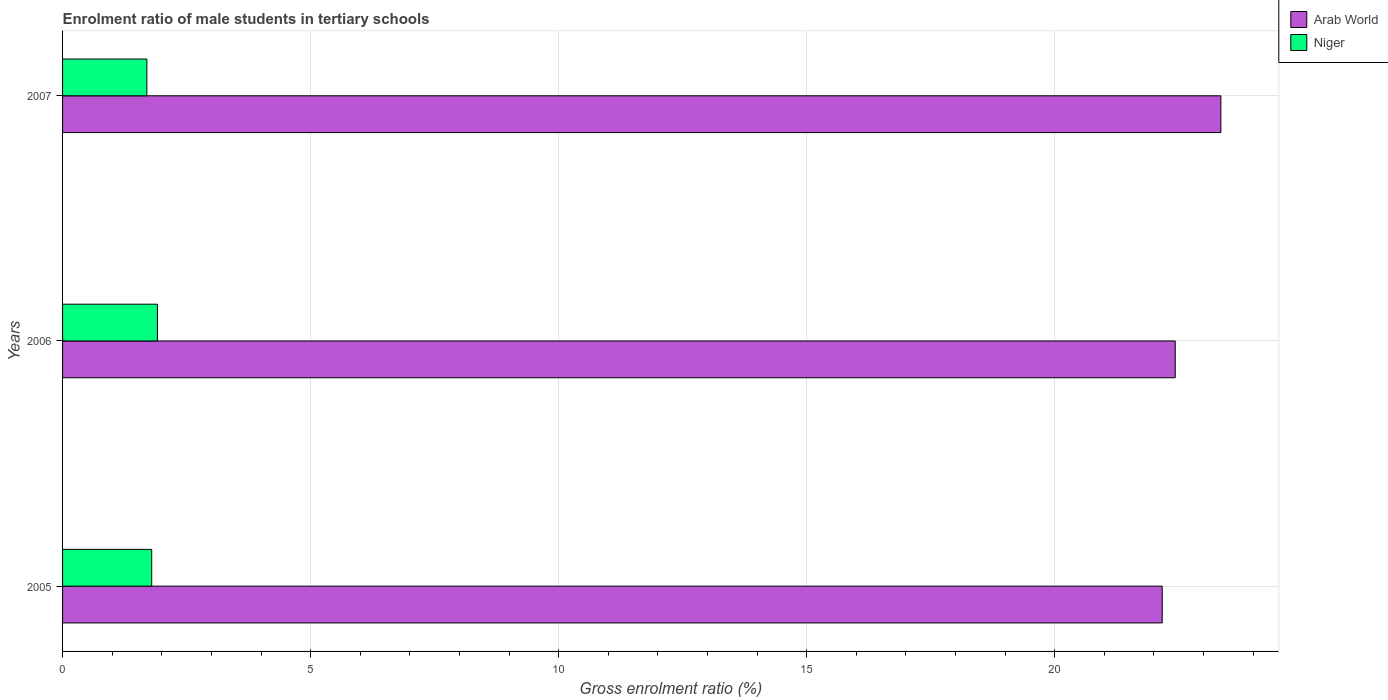How many groups of bars are there?
Your answer should be very brief. 3. Are the number of bars per tick equal to the number of legend labels?
Offer a very short reply. Yes. How many bars are there on the 2nd tick from the top?
Provide a succinct answer. 2. How many bars are there on the 1st tick from the bottom?
Offer a very short reply. 2. What is the label of the 2nd group of bars from the top?
Offer a terse response. 2006. In how many cases, is the number of bars for a given year not equal to the number of legend labels?
Provide a short and direct response. 0. What is the enrolment ratio of male students in tertiary schools in Niger in 2007?
Offer a very short reply. 1.7. Across all years, what is the maximum enrolment ratio of male students in tertiary schools in Niger?
Give a very brief answer. 1.91. Across all years, what is the minimum enrolment ratio of male students in tertiary schools in Niger?
Keep it short and to the point. 1.7. In which year was the enrolment ratio of male students in tertiary schools in Arab World minimum?
Your answer should be very brief. 2005. What is the total enrolment ratio of male students in tertiary schools in Arab World in the graph?
Your answer should be compact. 67.94. What is the difference between the enrolment ratio of male students in tertiary schools in Arab World in 2005 and that in 2007?
Keep it short and to the point. -1.18. What is the difference between the enrolment ratio of male students in tertiary schools in Arab World in 2006 and the enrolment ratio of male students in tertiary schools in Niger in 2007?
Your response must be concise. 20.73. What is the average enrolment ratio of male students in tertiary schools in Niger per year?
Make the answer very short. 1.8. In the year 2007, what is the difference between the enrolment ratio of male students in tertiary schools in Arab World and enrolment ratio of male students in tertiary schools in Niger?
Provide a succinct answer. 21.65. What is the ratio of the enrolment ratio of male students in tertiary schools in Arab World in 2005 to that in 2006?
Make the answer very short. 0.99. What is the difference between the highest and the second highest enrolment ratio of male students in tertiary schools in Niger?
Keep it short and to the point. 0.11. What is the difference between the highest and the lowest enrolment ratio of male students in tertiary schools in Niger?
Offer a terse response. 0.21. In how many years, is the enrolment ratio of male students in tertiary schools in Niger greater than the average enrolment ratio of male students in tertiary schools in Niger taken over all years?
Make the answer very short. 1. Is the sum of the enrolment ratio of male students in tertiary schools in Arab World in 2005 and 2006 greater than the maximum enrolment ratio of male students in tertiary schools in Niger across all years?
Your response must be concise. Yes. What does the 1st bar from the top in 2005 represents?
Offer a very short reply. Niger. What does the 2nd bar from the bottom in 2007 represents?
Ensure brevity in your answer.  Niger. How many bars are there?
Ensure brevity in your answer.  6. Are all the bars in the graph horizontal?
Your answer should be very brief. Yes. What is the difference between two consecutive major ticks on the X-axis?
Your response must be concise. 5. Are the values on the major ticks of X-axis written in scientific E-notation?
Ensure brevity in your answer.  No. Does the graph contain any zero values?
Your response must be concise. No. Does the graph contain grids?
Make the answer very short. Yes. How many legend labels are there?
Your answer should be compact. 2. How are the legend labels stacked?
Give a very brief answer. Vertical. What is the title of the graph?
Your answer should be compact. Enrolment ratio of male students in tertiary schools. Does "Marshall Islands" appear as one of the legend labels in the graph?
Provide a short and direct response. No. What is the Gross enrolment ratio (%) of Arab World in 2005?
Ensure brevity in your answer.  22.17. What is the Gross enrolment ratio (%) in Niger in 2005?
Make the answer very short. 1.8. What is the Gross enrolment ratio (%) of Arab World in 2006?
Ensure brevity in your answer.  22.43. What is the Gross enrolment ratio (%) in Niger in 2006?
Offer a terse response. 1.91. What is the Gross enrolment ratio (%) in Arab World in 2007?
Offer a very short reply. 23.35. What is the Gross enrolment ratio (%) in Niger in 2007?
Provide a succinct answer. 1.7. Across all years, what is the maximum Gross enrolment ratio (%) in Arab World?
Keep it short and to the point. 23.35. Across all years, what is the maximum Gross enrolment ratio (%) of Niger?
Ensure brevity in your answer.  1.91. Across all years, what is the minimum Gross enrolment ratio (%) of Arab World?
Ensure brevity in your answer.  22.17. Across all years, what is the minimum Gross enrolment ratio (%) in Niger?
Your answer should be very brief. 1.7. What is the total Gross enrolment ratio (%) of Arab World in the graph?
Make the answer very short. 67.94. What is the total Gross enrolment ratio (%) of Niger in the graph?
Offer a terse response. 5.41. What is the difference between the Gross enrolment ratio (%) in Arab World in 2005 and that in 2006?
Offer a terse response. -0.26. What is the difference between the Gross enrolment ratio (%) in Niger in 2005 and that in 2006?
Your response must be concise. -0.12. What is the difference between the Gross enrolment ratio (%) in Arab World in 2005 and that in 2007?
Give a very brief answer. -1.18. What is the difference between the Gross enrolment ratio (%) of Niger in 2005 and that in 2007?
Keep it short and to the point. 0.1. What is the difference between the Gross enrolment ratio (%) in Arab World in 2006 and that in 2007?
Keep it short and to the point. -0.92. What is the difference between the Gross enrolment ratio (%) in Niger in 2006 and that in 2007?
Provide a succinct answer. 0.21. What is the difference between the Gross enrolment ratio (%) in Arab World in 2005 and the Gross enrolment ratio (%) in Niger in 2006?
Your answer should be compact. 20.25. What is the difference between the Gross enrolment ratio (%) of Arab World in 2005 and the Gross enrolment ratio (%) of Niger in 2007?
Provide a short and direct response. 20.47. What is the difference between the Gross enrolment ratio (%) in Arab World in 2006 and the Gross enrolment ratio (%) in Niger in 2007?
Your response must be concise. 20.73. What is the average Gross enrolment ratio (%) in Arab World per year?
Your answer should be very brief. 22.65. What is the average Gross enrolment ratio (%) in Niger per year?
Your response must be concise. 1.8. In the year 2005, what is the difference between the Gross enrolment ratio (%) of Arab World and Gross enrolment ratio (%) of Niger?
Give a very brief answer. 20.37. In the year 2006, what is the difference between the Gross enrolment ratio (%) in Arab World and Gross enrolment ratio (%) in Niger?
Keep it short and to the point. 20.52. In the year 2007, what is the difference between the Gross enrolment ratio (%) of Arab World and Gross enrolment ratio (%) of Niger?
Keep it short and to the point. 21.65. What is the ratio of the Gross enrolment ratio (%) in Arab World in 2005 to that in 2006?
Offer a very short reply. 0.99. What is the ratio of the Gross enrolment ratio (%) of Niger in 2005 to that in 2006?
Keep it short and to the point. 0.94. What is the ratio of the Gross enrolment ratio (%) of Arab World in 2005 to that in 2007?
Your answer should be compact. 0.95. What is the ratio of the Gross enrolment ratio (%) of Niger in 2005 to that in 2007?
Keep it short and to the point. 1.06. What is the ratio of the Gross enrolment ratio (%) in Arab World in 2006 to that in 2007?
Ensure brevity in your answer.  0.96. What is the ratio of the Gross enrolment ratio (%) of Niger in 2006 to that in 2007?
Offer a terse response. 1.13. What is the difference between the highest and the second highest Gross enrolment ratio (%) of Arab World?
Your answer should be compact. 0.92. What is the difference between the highest and the second highest Gross enrolment ratio (%) in Niger?
Provide a succinct answer. 0.12. What is the difference between the highest and the lowest Gross enrolment ratio (%) of Arab World?
Offer a terse response. 1.18. What is the difference between the highest and the lowest Gross enrolment ratio (%) in Niger?
Ensure brevity in your answer.  0.21. 